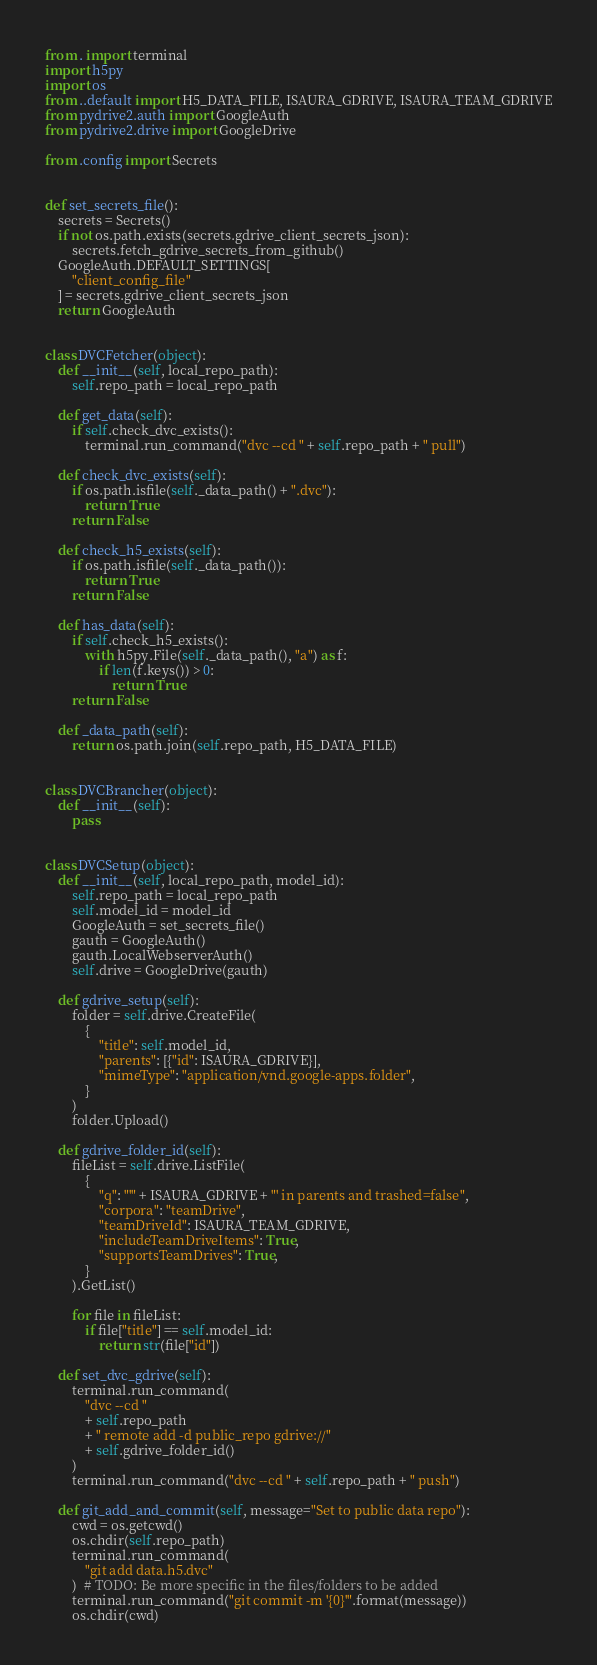<code> <loc_0><loc_0><loc_500><loc_500><_Python_>from . import terminal
import h5py
import os
from ..default import H5_DATA_FILE, ISAURA_GDRIVE, ISAURA_TEAM_GDRIVE
from pydrive2.auth import GoogleAuth
from pydrive2.drive import GoogleDrive

from .config import Secrets


def set_secrets_file():
    secrets = Secrets()
    if not os.path.exists(secrets.gdrive_client_secrets_json):
        secrets.fetch_gdrive_secrets_from_github()
    GoogleAuth.DEFAULT_SETTINGS[
        "client_config_file"
    ] = secrets.gdrive_client_secrets_json
    return GoogleAuth


class DVCFetcher(object):
    def __init__(self, local_repo_path):
        self.repo_path = local_repo_path

    def get_data(self):
        if self.check_dvc_exists():
            terminal.run_command("dvc --cd " + self.repo_path + " pull")

    def check_dvc_exists(self):
        if os.path.isfile(self._data_path() + ".dvc"):
            return True
        return False

    def check_h5_exists(self):
        if os.path.isfile(self._data_path()):
            return True
        return False

    def has_data(self):
        if self.check_h5_exists():
            with h5py.File(self._data_path(), "a") as f:
                if len(f.keys()) > 0:
                    return True
        return False

    def _data_path(self):
        return os.path.join(self.repo_path, H5_DATA_FILE)


class DVCBrancher(object):
    def __init__(self):
        pass


class DVCSetup(object):
    def __init__(self, local_repo_path, model_id):
        self.repo_path = local_repo_path
        self.model_id = model_id
        GoogleAuth = set_secrets_file()
        gauth = GoogleAuth()
        gauth.LocalWebserverAuth()
        self.drive = GoogleDrive(gauth)

    def gdrive_setup(self):
        folder = self.drive.CreateFile(
            {
                "title": self.model_id,
                "parents": [{"id": ISAURA_GDRIVE}],
                "mimeType": "application/vnd.google-apps.folder",
            }
        )
        folder.Upload()

    def gdrive_folder_id(self):
        fileList = self.drive.ListFile(
            {
                "q": "'" + ISAURA_GDRIVE + "' in parents and trashed=false",
                "corpora": "teamDrive",
                "teamDriveId": ISAURA_TEAM_GDRIVE,
                "includeTeamDriveItems": True,
                "supportsTeamDrives": True,
            }
        ).GetList()

        for file in fileList:
            if file["title"] == self.model_id:
                return str(file["id"])

    def set_dvc_gdrive(self):
        terminal.run_command(
            "dvc --cd "
            + self.repo_path
            + " remote add -d public_repo gdrive://"
            + self.gdrive_folder_id()
        )
        terminal.run_command("dvc --cd " + self.repo_path + " push")

    def git_add_and_commit(self, message="Set to public data repo"):
        cwd = os.getcwd()
        os.chdir(self.repo_path)
        terminal.run_command(
            "git add data.h5.dvc"
        )  # TODO: Be more specific in the files/folders to be added
        terminal.run_command("git commit -m '{0}'".format(message))
        os.chdir(cwd)
</code> 